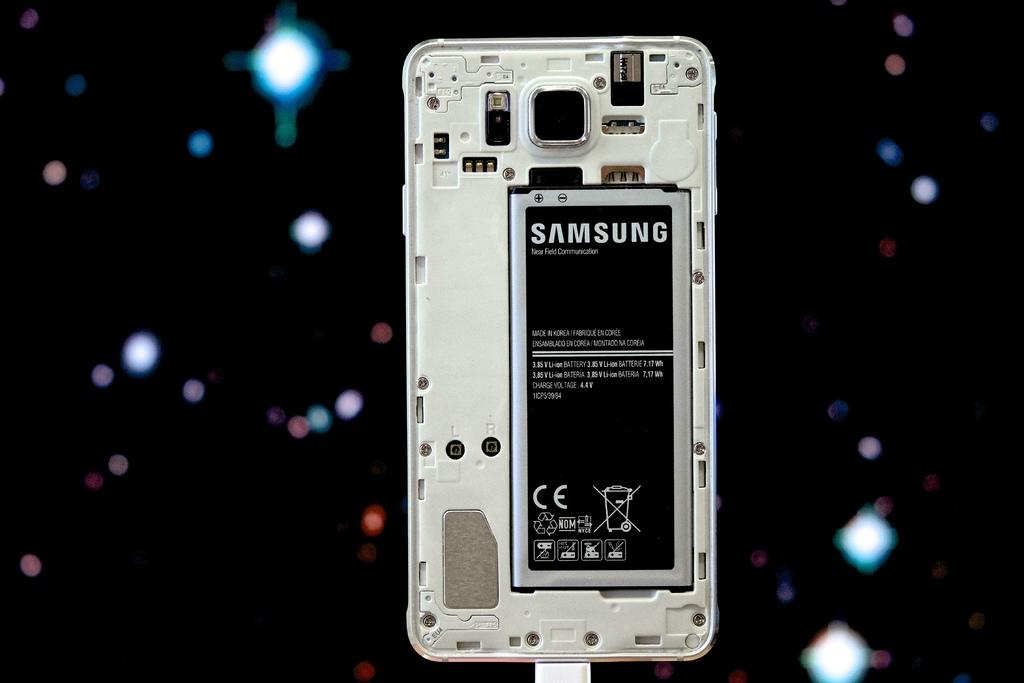<image>
Summarize the visual content of the image. The back of a smartphone with the word Samsung printed on the battery 